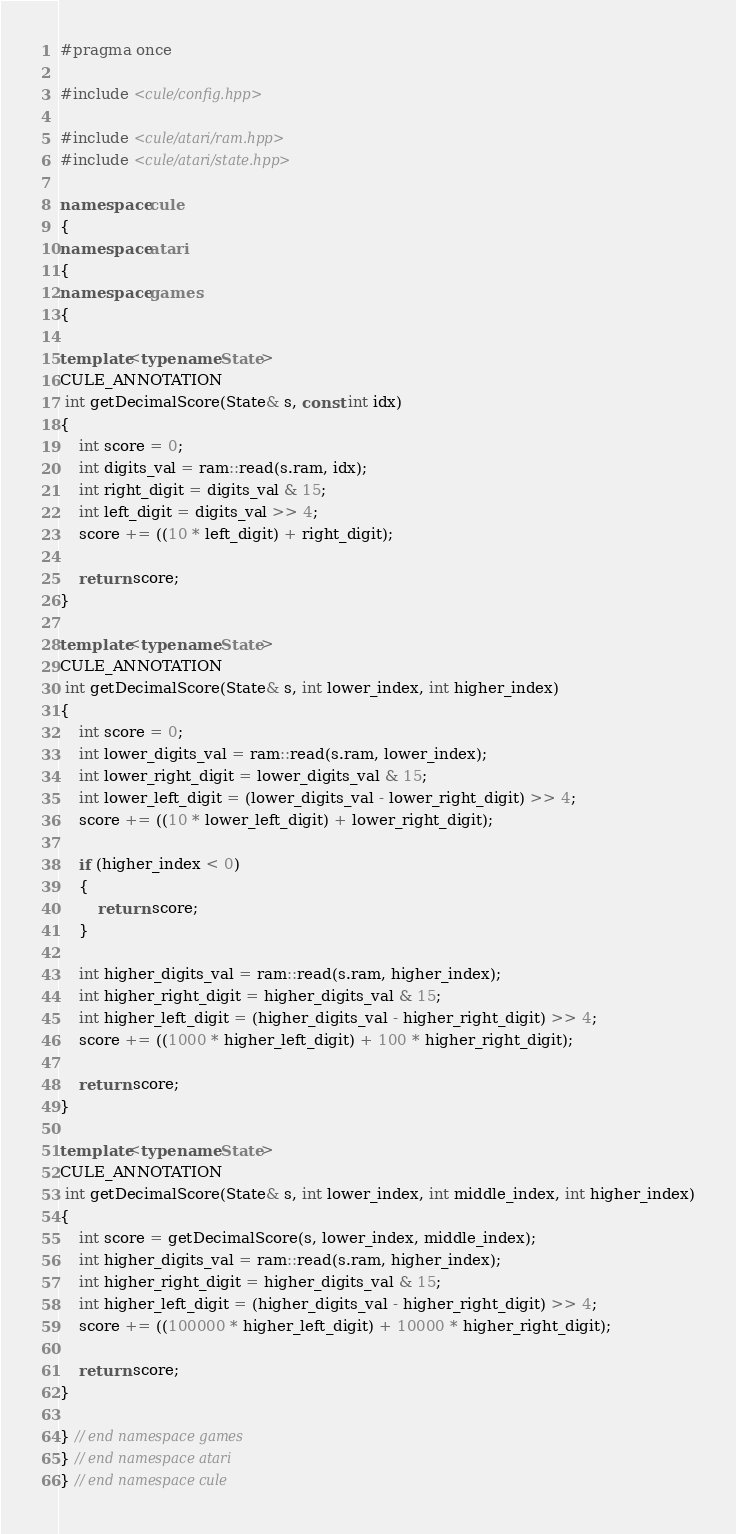<code> <loc_0><loc_0><loc_500><loc_500><_C++_>#pragma once

#include <cule/config.hpp>

#include <cule/atari/ram.hpp>
#include <cule/atari/state.hpp>

namespace cule
{
namespace atari
{
namespace games
{

template<typename State>
CULE_ANNOTATION
 int getDecimalScore(State& s, const int idx)
{
    int score = 0;
    int digits_val = ram::read(s.ram, idx);
    int right_digit = digits_val & 15;
    int left_digit = digits_val >> 4;
    score += ((10 * left_digit) + right_digit);

    return score;
}

template<typename State>
CULE_ANNOTATION
 int getDecimalScore(State& s, int lower_index, int higher_index)
{
    int score = 0;
    int lower_digits_val = ram::read(s.ram, lower_index);
    int lower_right_digit = lower_digits_val & 15;
    int lower_left_digit = (lower_digits_val - lower_right_digit) >> 4;
    score += ((10 * lower_left_digit) + lower_right_digit);

    if (higher_index < 0)
    {
        return score;
    }

    int higher_digits_val = ram::read(s.ram, higher_index);
    int higher_right_digit = higher_digits_val & 15;
    int higher_left_digit = (higher_digits_val - higher_right_digit) >> 4;
    score += ((1000 * higher_left_digit) + 100 * higher_right_digit);

    return score;
}

template<typename State>
CULE_ANNOTATION
 int getDecimalScore(State& s, int lower_index, int middle_index, int higher_index)
{
    int score = getDecimalScore(s, lower_index, middle_index);
    int higher_digits_val = ram::read(s.ram, higher_index);
    int higher_right_digit = higher_digits_val & 15;
    int higher_left_digit = (higher_digits_val - higher_right_digit) >> 4;
    score += ((100000 * higher_left_digit) + 10000 * higher_right_digit);

    return score;
}

} // end namespace games
} // end namespace atari
} // end namespace cule

</code> 